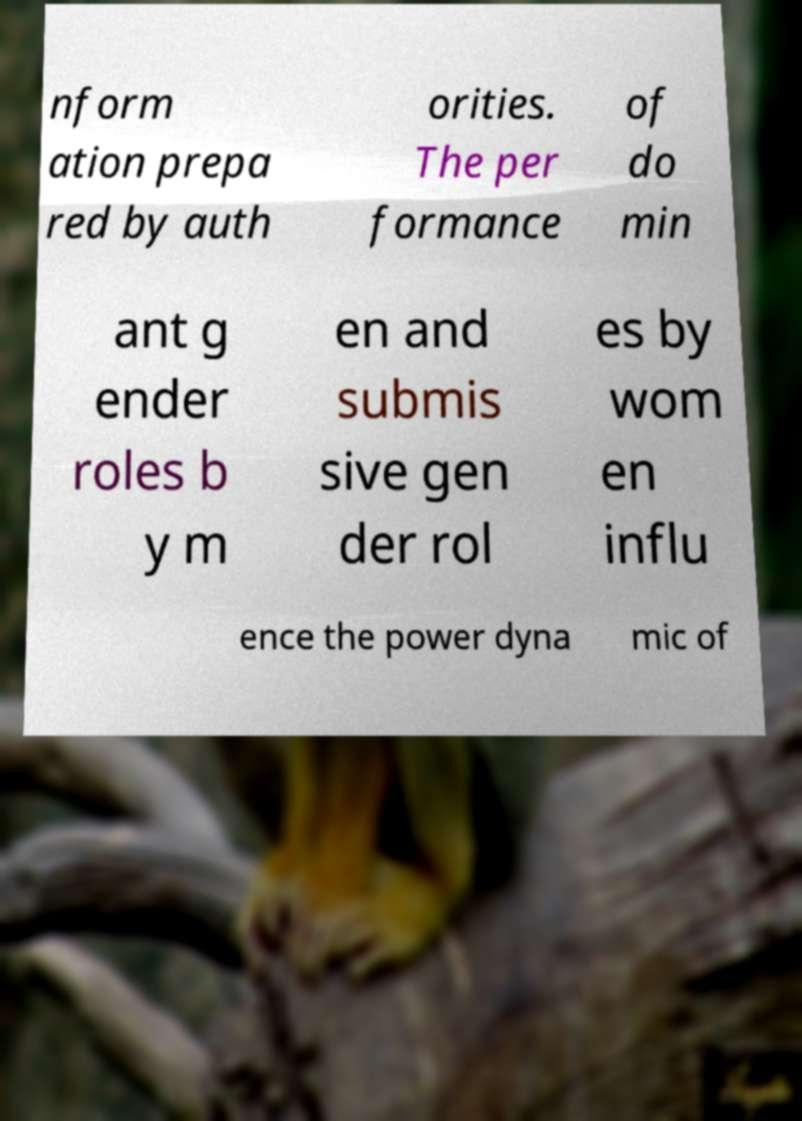Can you read and provide the text displayed in the image?This photo seems to have some interesting text. Can you extract and type it out for me? nform ation prepa red by auth orities. The per formance of do min ant g ender roles b y m en and submis sive gen der rol es by wom en influ ence the power dyna mic of 